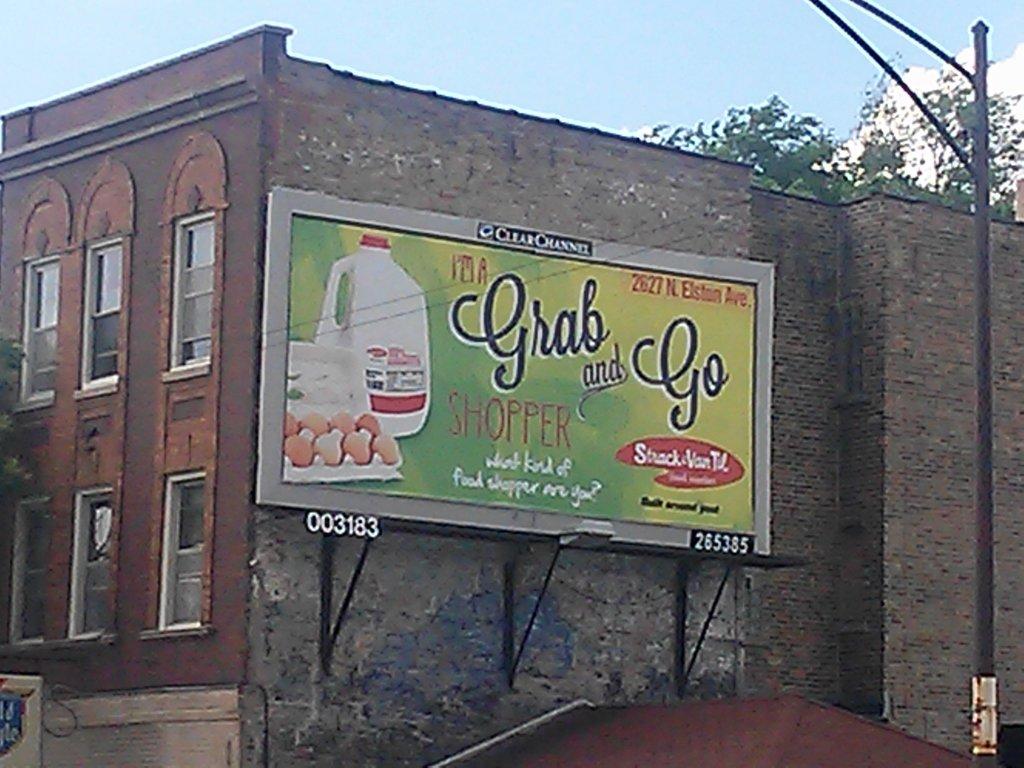What is the name of the store featured on this billboard?
Offer a very short reply. Unanswerable. What is the address of this store?
Ensure brevity in your answer.  2627 n. elston ave. 